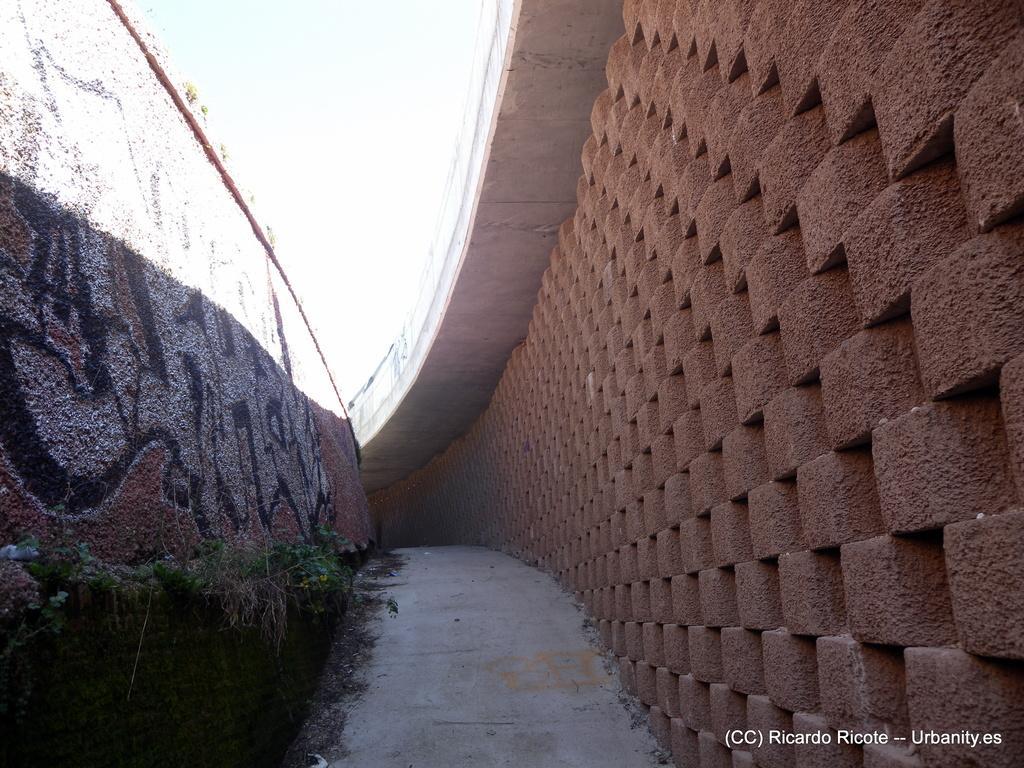Describe this image in one or two sentences. In this image on the right side and left side there is a wall and some grass. At the bottom there is a walkway and at the top of the image there is sky, and at the bottom of the image there is some text. 